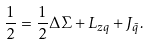<formula> <loc_0><loc_0><loc_500><loc_500>\frac { 1 } { 2 } = \frac { 1 } { 2 } \Delta \Sigma + L _ { z q } + J _ { \bar { q } } .</formula> 